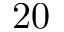Convert formula to latex. <formula><loc_0><loc_0><loc_500><loc_500>2 0</formula> 